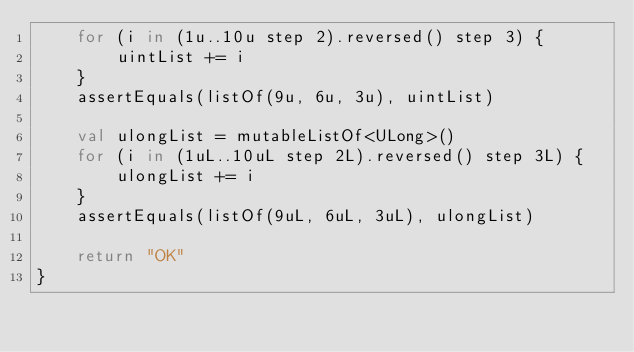Convert code to text. <code><loc_0><loc_0><loc_500><loc_500><_Kotlin_>    for (i in (1u..10u step 2).reversed() step 3) {
        uintList += i
    }
    assertEquals(listOf(9u, 6u, 3u), uintList)

    val ulongList = mutableListOf<ULong>()
    for (i in (1uL..10uL step 2L).reversed() step 3L) {
        ulongList += i
    }
    assertEquals(listOf(9uL, 6uL, 3uL), ulongList)

    return "OK"
}</code> 